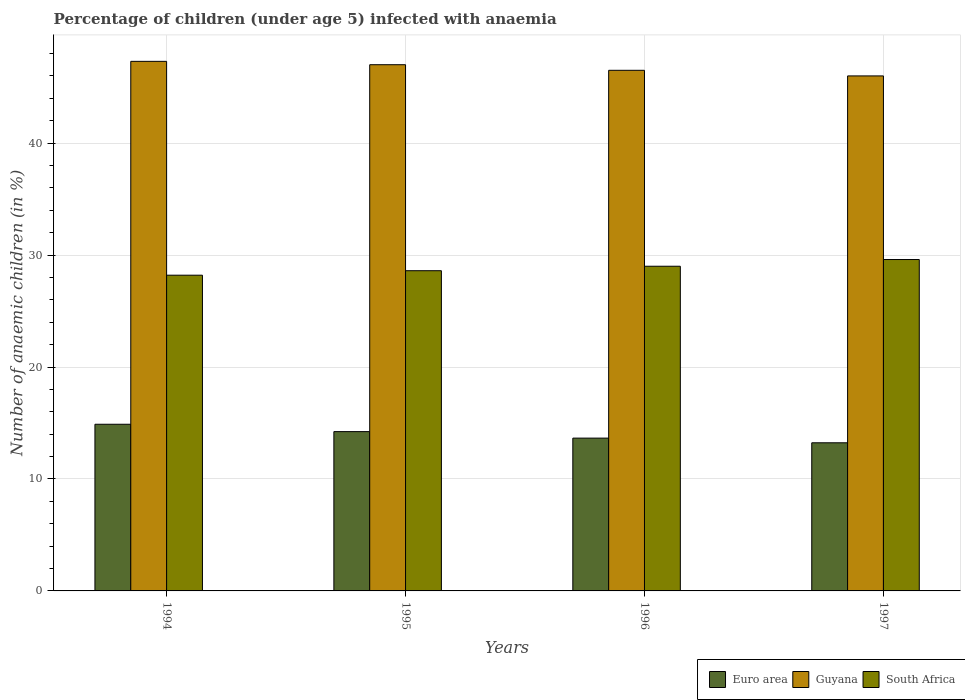How many different coloured bars are there?
Offer a terse response. 3. How many groups of bars are there?
Your answer should be compact. 4. Are the number of bars per tick equal to the number of legend labels?
Offer a very short reply. Yes. Are the number of bars on each tick of the X-axis equal?
Your answer should be very brief. Yes. How many bars are there on the 2nd tick from the left?
Your answer should be compact. 3. What is the label of the 1st group of bars from the left?
Your answer should be compact. 1994. In how many cases, is the number of bars for a given year not equal to the number of legend labels?
Ensure brevity in your answer.  0. Across all years, what is the maximum percentage of children infected with anaemia in in Guyana?
Provide a short and direct response. 47.3. Across all years, what is the minimum percentage of children infected with anaemia in in Euro area?
Offer a terse response. 13.23. In which year was the percentage of children infected with anaemia in in South Africa maximum?
Your response must be concise. 1997. What is the total percentage of children infected with anaemia in in Guyana in the graph?
Your response must be concise. 186.8. What is the difference between the percentage of children infected with anaemia in in Euro area in 1996 and that in 1997?
Provide a succinct answer. 0.42. What is the difference between the percentage of children infected with anaemia in in Euro area in 1997 and the percentage of children infected with anaemia in in Guyana in 1996?
Offer a terse response. -33.27. What is the average percentage of children infected with anaemia in in South Africa per year?
Give a very brief answer. 28.85. In the year 1996, what is the difference between the percentage of children infected with anaemia in in South Africa and percentage of children infected with anaemia in in Guyana?
Make the answer very short. -17.5. In how many years, is the percentage of children infected with anaemia in in Guyana greater than 24 %?
Your answer should be compact. 4. What is the ratio of the percentage of children infected with anaemia in in Guyana in 1995 to that in 1997?
Offer a very short reply. 1.02. Is the percentage of children infected with anaemia in in South Africa in 1994 less than that in 1996?
Make the answer very short. Yes. What is the difference between the highest and the second highest percentage of children infected with anaemia in in Euro area?
Your answer should be compact. 0.66. What is the difference between the highest and the lowest percentage of children infected with anaemia in in South Africa?
Make the answer very short. 1.4. What does the 1st bar from the right in 1996 represents?
Provide a succinct answer. South Africa. Is it the case that in every year, the sum of the percentage of children infected with anaemia in in South Africa and percentage of children infected with anaemia in in Euro area is greater than the percentage of children infected with anaemia in in Guyana?
Offer a terse response. No. How many bars are there?
Offer a terse response. 12. Are all the bars in the graph horizontal?
Your answer should be very brief. No. How many years are there in the graph?
Give a very brief answer. 4. What is the difference between two consecutive major ticks on the Y-axis?
Your answer should be very brief. 10. Does the graph contain any zero values?
Your answer should be very brief. No. Does the graph contain grids?
Your answer should be very brief. Yes. Where does the legend appear in the graph?
Offer a terse response. Bottom right. What is the title of the graph?
Give a very brief answer. Percentage of children (under age 5) infected with anaemia. What is the label or title of the Y-axis?
Provide a short and direct response. Number of anaemic children (in %). What is the Number of anaemic children (in %) of Euro area in 1994?
Make the answer very short. 14.89. What is the Number of anaemic children (in %) in Guyana in 1994?
Your answer should be very brief. 47.3. What is the Number of anaemic children (in %) in South Africa in 1994?
Make the answer very short. 28.2. What is the Number of anaemic children (in %) in Euro area in 1995?
Your answer should be compact. 14.23. What is the Number of anaemic children (in %) in South Africa in 1995?
Provide a short and direct response. 28.6. What is the Number of anaemic children (in %) of Euro area in 1996?
Your response must be concise. 13.65. What is the Number of anaemic children (in %) in Guyana in 1996?
Offer a terse response. 46.5. What is the Number of anaemic children (in %) of Euro area in 1997?
Your answer should be very brief. 13.23. What is the Number of anaemic children (in %) of South Africa in 1997?
Your answer should be very brief. 29.6. Across all years, what is the maximum Number of anaemic children (in %) in Euro area?
Your response must be concise. 14.89. Across all years, what is the maximum Number of anaemic children (in %) in Guyana?
Offer a very short reply. 47.3. Across all years, what is the maximum Number of anaemic children (in %) of South Africa?
Your answer should be compact. 29.6. Across all years, what is the minimum Number of anaemic children (in %) of Euro area?
Offer a terse response. 13.23. Across all years, what is the minimum Number of anaemic children (in %) of Guyana?
Keep it short and to the point. 46. Across all years, what is the minimum Number of anaemic children (in %) in South Africa?
Provide a succinct answer. 28.2. What is the total Number of anaemic children (in %) of Euro area in the graph?
Ensure brevity in your answer.  55.99. What is the total Number of anaemic children (in %) in Guyana in the graph?
Offer a very short reply. 186.8. What is the total Number of anaemic children (in %) in South Africa in the graph?
Your answer should be compact. 115.4. What is the difference between the Number of anaemic children (in %) of Euro area in 1994 and that in 1995?
Provide a short and direct response. 0.66. What is the difference between the Number of anaemic children (in %) of Euro area in 1994 and that in 1996?
Give a very brief answer. 1.24. What is the difference between the Number of anaemic children (in %) of Guyana in 1994 and that in 1996?
Provide a short and direct response. 0.8. What is the difference between the Number of anaemic children (in %) in Euro area in 1994 and that in 1997?
Keep it short and to the point. 1.66. What is the difference between the Number of anaemic children (in %) of South Africa in 1994 and that in 1997?
Your response must be concise. -1.4. What is the difference between the Number of anaemic children (in %) of Euro area in 1995 and that in 1996?
Offer a terse response. 0.58. What is the difference between the Number of anaemic children (in %) of South Africa in 1995 and that in 1996?
Offer a very short reply. -0.4. What is the difference between the Number of anaemic children (in %) in Euro area in 1996 and that in 1997?
Provide a succinct answer. 0.42. What is the difference between the Number of anaemic children (in %) of Guyana in 1996 and that in 1997?
Keep it short and to the point. 0.5. What is the difference between the Number of anaemic children (in %) in South Africa in 1996 and that in 1997?
Make the answer very short. -0.6. What is the difference between the Number of anaemic children (in %) of Euro area in 1994 and the Number of anaemic children (in %) of Guyana in 1995?
Ensure brevity in your answer.  -32.11. What is the difference between the Number of anaemic children (in %) in Euro area in 1994 and the Number of anaemic children (in %) in South Africa in 1995?
Provide a succinct answer. -13.71. What is the difference between the Number of anaemic children (in %) in Guyana in 1994 and the Number of anaemic children (in %) in South Africa in 1995?
Ensure brevity in your answer.  18.7. What is the difference between the Number of anaemic children (in %) in Euro area in 1994 and the Number of anaemic children (in %) in Guyana in 1996?
Make the answer very short. -31.61. What is the difference between the Number of anaemic children (in %) in Euro area in 1994 and the Number of anaemic children (in %) in South Africa in 1996?
Your answer should be very brief. -14.11. What is the difference between the Number of anaemic children (in %) of Euro area in 1994 and the Number of anaemic children (in %) of Guyana in 1997?
Your response must be concise. -31.11. What is the difference between the Number of anaemic children (in %) in Euro area in 1994 and the Number of anaemic children (in %) in South Africa in 1997?
Make the answer very short. -14.71. What is the difference between the Number of anaemic children (in %) in Guyana in 1994 and the Number of anaemic children (in %) in South Africa in 1997?
Give a very brief answer. 17.7. What is the difference between the Number of anaemic children (in %) in Euro area in 1995 and the Number of anaemic children (in %) in Guyana in 1996?
Your answer should be compact. -32.27. What is the difference between the Number of anaemic children (in %) in Euro area in 1995 and the Number of anaemic children (in %) in South Africa in 1996?
Make the answer very short. -14.77. What is the difference between the Number of anaemic children (in %) of Euro area in 1995 and the Number of anaemic children (in %) of Guyana in 1997?
Provide a succinct answer. -31.77. What is the difference between the Number of anaemic children (in %) of Euro area in 1995 and the Number of anaemic children (in %) of South Africa in 1997?
Your answer should be compact. -15.37. What is the difference between the Number of anaemic children (in %) in Euro area in 1996 and the Number of anaemic children (in %) in Guyana in 1997?
Your response must be concise. -32.35. What is the difference between the Number of anaemic children (in %) in Euro area in 1996 and the Number of anaemic children (in %) in South Africa in 1997?
Offer a terse response. -15.95. What is the difference between the Number of anaemic children (in %) of Guyana in 1996 and the Number of anaemic children (in %) of South Africa in 1997?
Ensure brevity in your answer.  16.9. What is the average Number of anaemic children (in %) of Euro area per year?
Ensure brevity in your answer.  14. What is the average Number of anaemic children (in %) in Guyana per year?
Keep it short and to the point. 46.7. What is the average Number of anaemic children (in %) in South Africa per year?
Keep it short and to the point. 28.85. In the year 1994, what is the difference between the Number of anaemic children (in %) of Euro area and Number of anaemic children (in %) of Guyana?
Make the answer very short. -32.41. In the year 1994, what is the difference between the Number of anaemic children (in %) in Euro area and Number of anaemic children (in %) in South Africa?
Ensure brevity in your answer.  -13.31. In the year 1994, what is the difference between the Number of anaemic children (in %) in Guyana and Number of anaemic children (in %) in South Africa?
Offer a terse response. 19.1. In the year 1995, what is the difference between the Number of anaemic children (in %) of Euro area and Number of anaemic children (in %) of Guyana?
Your response must be concise. -32.77. In the year 1995, what is the difference between the Number of anaemic children (in %) in Euro area and Number of anaemic children (in %) in South Africa?
Provide a succinct answer. -14.37. In the year 1996, what is the difference between the Number of anaemic children (in %) of Euro area and Number of anaemic children (in %) of Guyana?
Your response must be concise. -32.85. In the year 1996, what is the difference between the Number of anaemic children (in %) in Euro area and Number of anaemic children (in %) in South Africa?
Your answer should be compact. -15.35. In the year 1997, what is the difference between the Number of anaemic children (in %) in Euro area and Number of anaemic children (in %) in Guyana?
Keep it short and to the point. -32.77. In the year 1997, what is the difference between the Number of anaemic children (in %) in Euro area and Number of anaemic children (in %) in South Africa?
Ensure brevity in your answer.  -16.37. In the year 1997, what is the difference between the Number of anaemic children (in %) in Guyana and Number of anaemic children (in %) in South Africa?
Your response must be concise. 16.4. What is the ratio of the Number of anaemic children (in %) of Euro area in 1994 to that in 1995?
Your answer should be compact. 1.05. What is the ratio of the Number of anaemic children (in %) in Guyana in 1994 to that in 1995?
Offer a terse response. 1.01. What is the ratio of the Number of anaemic children (in %) in South Africa in 1994 to that in 1995?
Your response must be concise. 0.99. What is the ratio of the Number of anaemic children (in %) in Euro area in 1994 to that in 1996?
Your answer should be compact. 1.09. What is the ratio of the Number of anaemic children (in %) of Guyana in 1994 to that in 1996?
Your response must be concise. 1.02. What is the ratio of the Number of anaemic children (in %) in South Africa in 1994 to that in 1996?
Your answer should be compact. 0.97. What is the ratio of the Number of anaemic children (in %) in Euro area in 1994 to that in 1997?
Your answer should be very brief. 1.13. What is the ratio of the Number of anaemic children (in %) in Guyana in 1994 to that in 1997?
Your answer should be compact. 1.03. What is the ratio of the Number of anaemic children (in %) of South Africa in 1994 to that in 1997?
Your response must be concise. 0.95. What is the ratio of the Number of anaemic children (in %) of Euro area in 1995 to that in 1996?
Offer a terse response. 1.04. What is the ratio of the Number of anaemic children (in %) in Guyana in 1995 to that in 1996?
Your answer should be compact. 1.01. What is the ratio of the Number of anaemic children (in %) of South Africa in 1995 to that in 1996?
Give a very brief answer. 0.99. What is the ratio of the Number of anaemic children (in %) in Euro area in 1995 to that in 1997?
Your answer should be compact. 1.08. What is the ratio of the Number of anaemic children (in %) of Guyana in 1995 to that in 1997?
Your answer should be very brief. 1.02. What is the ratio of the Number of anaemic children (in %) in South Africa in 1995 to that in 1997?
Provide a succinct answer. 0.97. What is the ratio of the Number of anaemic children (in %) in Euro area in 1996 to that in 1997?
Your answer should be very brief. 1.03. What is the ratio of the Number of anaemic children (in %) in Guyana in 1996 to that in 1997?
Your response must be concise. 1.01. What is the ratio of the Number of anaemic children (in %) in South Africa in 1996 to that in 1997?
Provide a succinct answer. 0.98. What is the difference between the highest and the second highest Number of anaemic children (in %) in Euro area?
Provide a succinct answer. 0.66. What is the difference between the highest and the lowest Number of anaemic children (in %) in Euro area?
Offer a terse response. 1.66. 